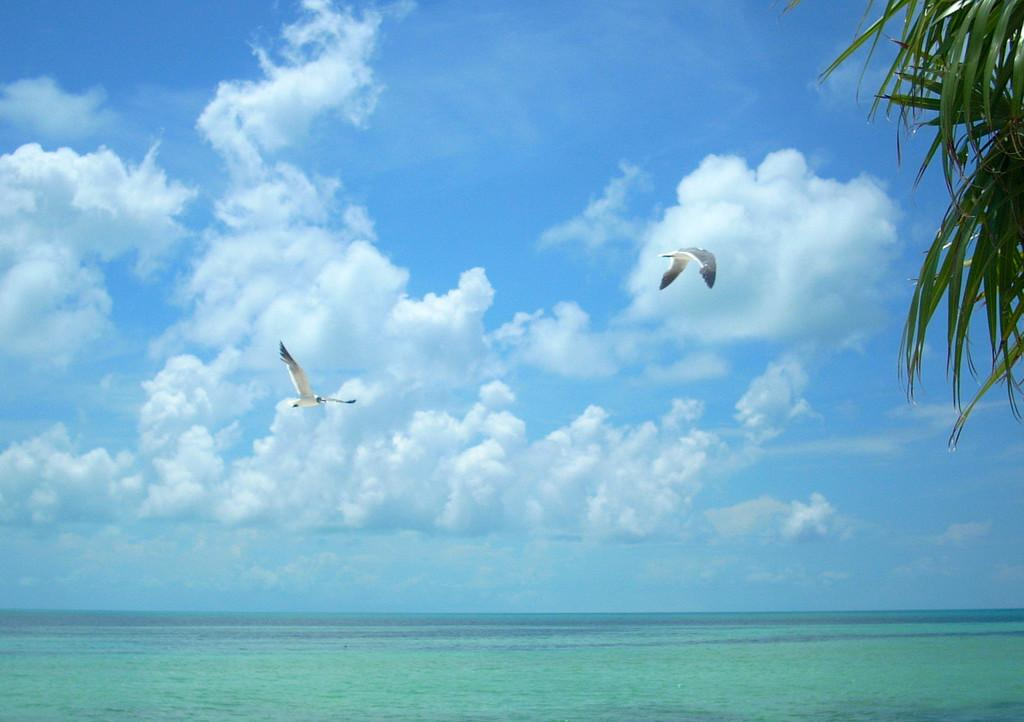How many birds can be seen in the sky in the image? There are two birds in the sky in the image. What is the condition of the sky in the image? The sky is cloudy in the image. What type of natural feature is visible in the image? There is an ocean visible in the image. What type of plant is present in the image? There is a tree in the image. What type of brush can be seen in the hands of the birds in the image? There are no brushes or hands visible in the image; it features two birds in the sky, a cloudy sky, an ocean, and a tree. 